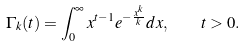Convert formula to latex. <formula><loc_0><loc_0><loc_500><loc_500>\Gamma _ { k } ( t ) = \int _ { 0 } ^ { \infty } x ^ { t - 1 } e ^ { - \frac { x ^ { k } } { k } } d x , \quad t > 0 .</formula> 